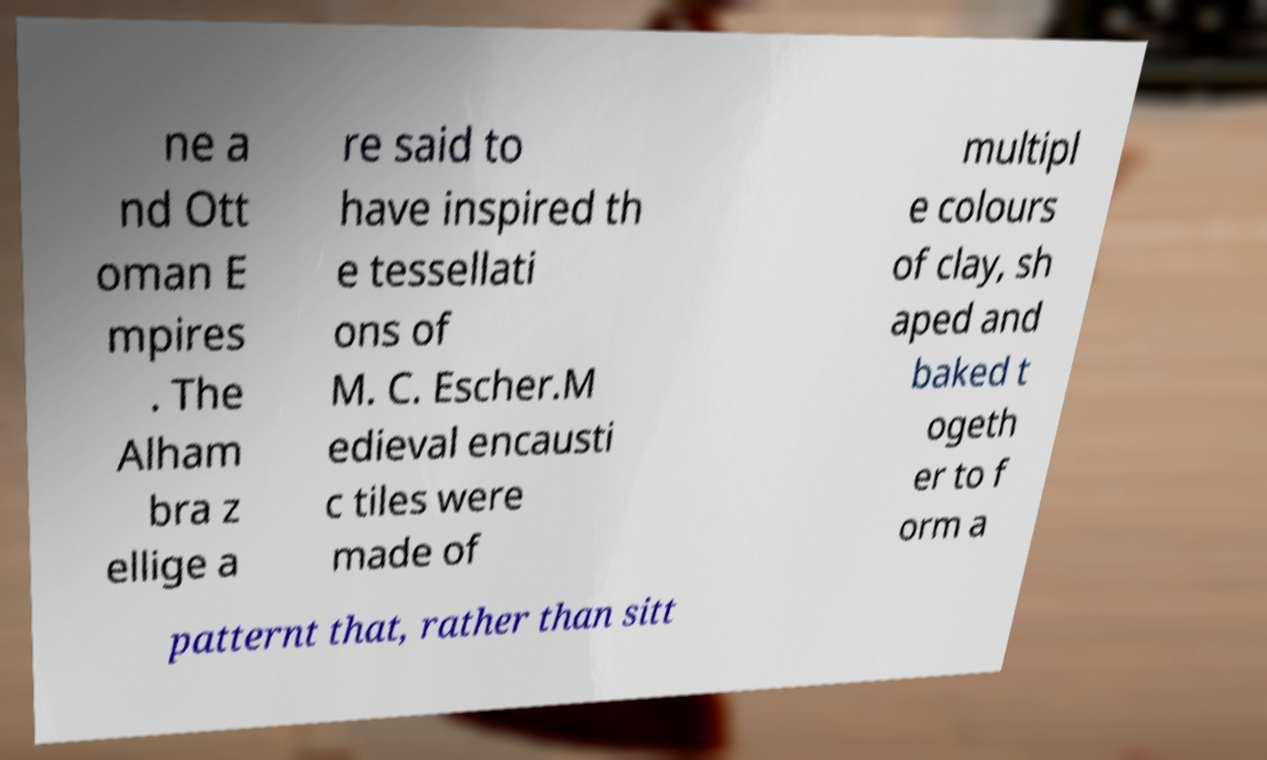What messages or text are displayed in this image? I need them in a readable, typed format. ne a nd Ott oman E mpires . The Alham bra z ellige a re said to have inspired th e tessellati ons of M. C. Escher.M edieval encausti c tiles were made of multipl e colours of clay, sh aped and baked t ogeth er to f orm a patternt that, rather than sitt 